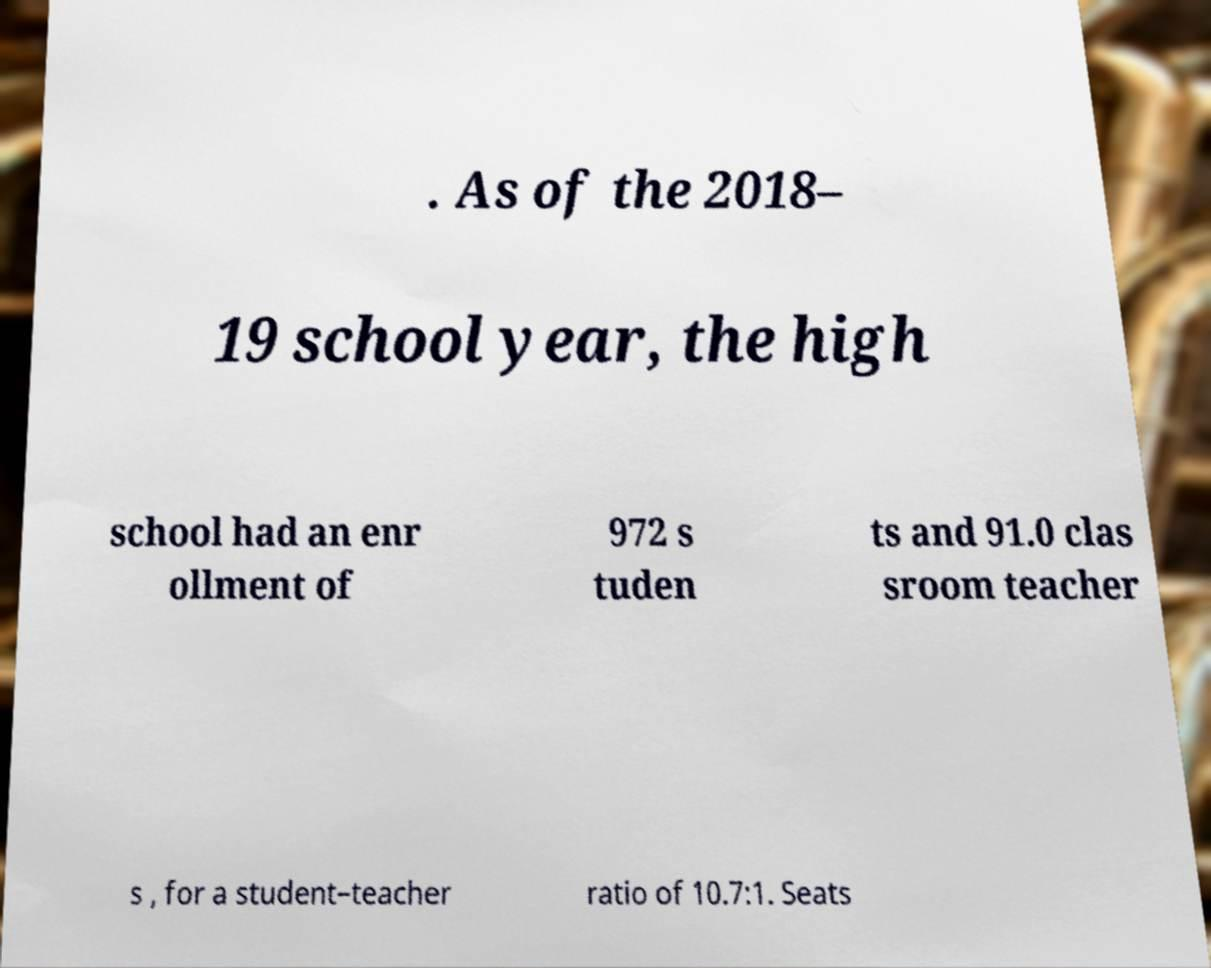There's text embedded in this image that I need extracted. Can you transcribe it verbatim? . As of the 2018– 19 school year, the high school had an enr ollment of 972 s tuden ts and 91.0 clas sroom teacher s , for a student–teacher ratio of 10.7:1. Seats 